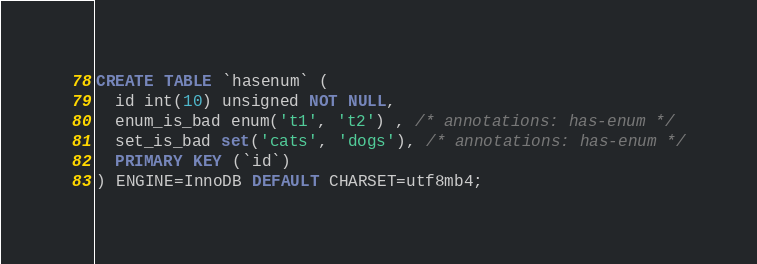<code> <loc_0><loc_0><loc_500><loc_500><_SQL_>CREATE TABLE `hasenum` (
  id int(10) unsigned NOT NULL,
  enum_is_bad enum('t1', 't2') , /* annotations: has-enum */
  set_is_bad set('cats', 'dogs'), /* annotations: has-enum */
  PRIMARY KEY (`id`)
) ENGINE=InnoDB DEFAULT CHARSET=utf8mb4;</code> 